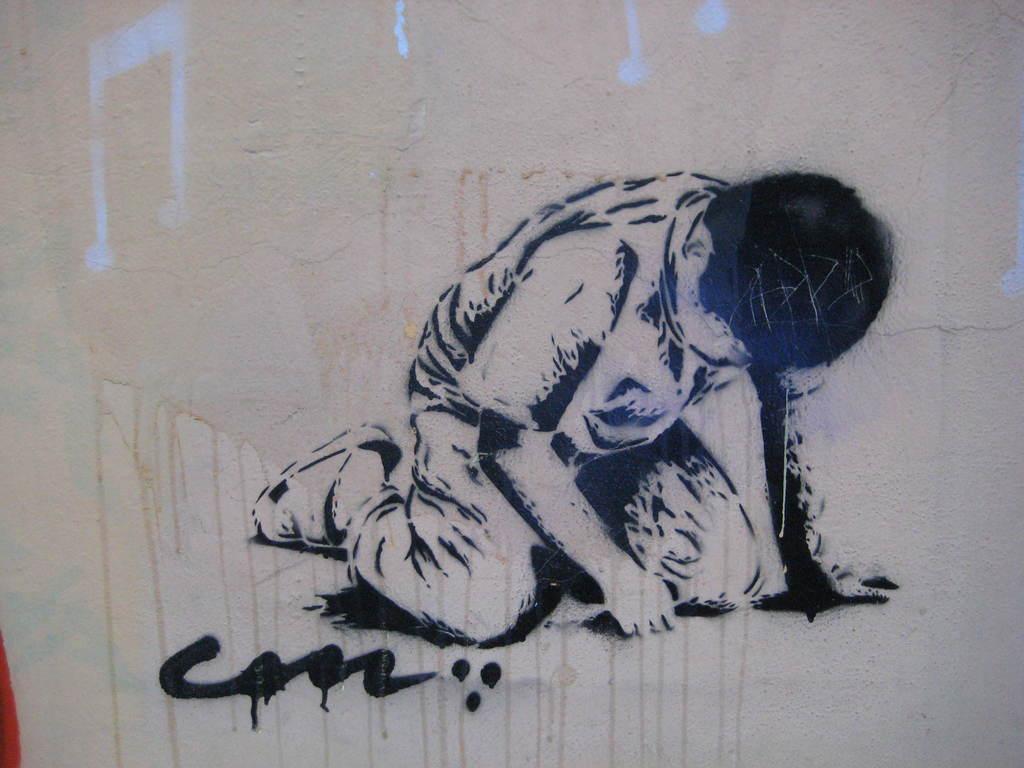Could you give a brief overview of what you see in this image? In this picture we can see the wall with a painting of a person and some symbols on it. 